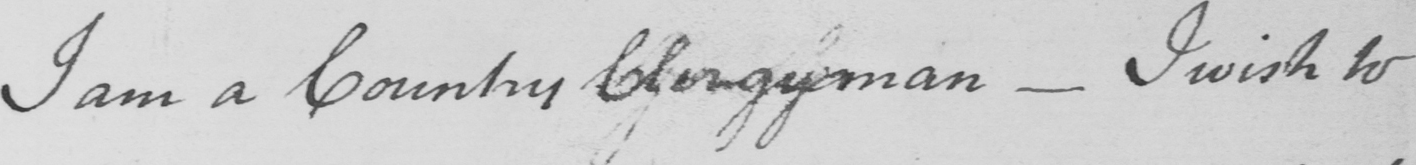What text is written in this handwritten line? I am a Country Clergyman  _  I wish to 